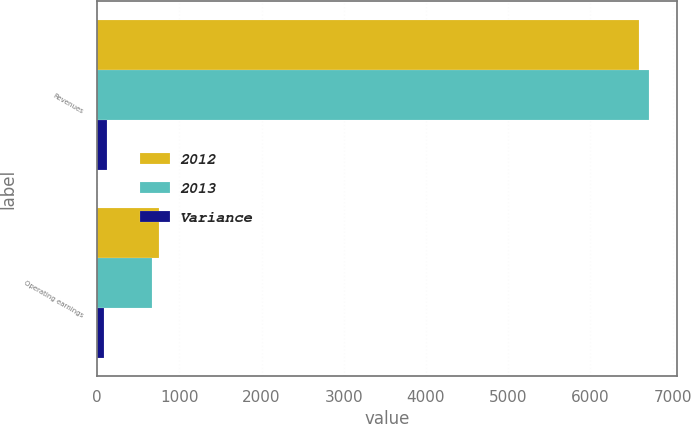Convert chart. <chart><loc_0><loc_0><loc_500><loc_500><stacked_bar_chart><ecel><fcel>Revenues<fcel>Operating earnings<nl><fcel>2012<fcel>6592<fcel>750<nl><fcel>2013<fcel>6712<fcel>666<nl><fcel>Variance<fcel>120<fcel>84<nl></chart> 